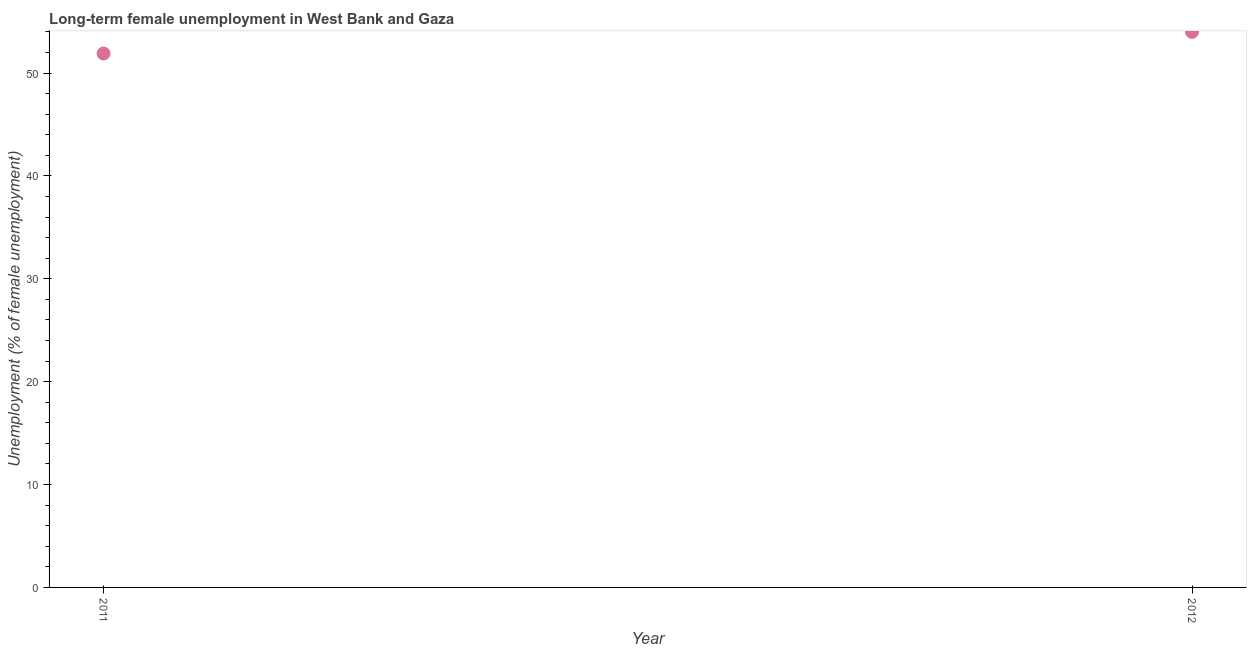What is the long-term female unemployment in 2011?
Give a very brief answer. 51.9. Across all years, what is the maximum long-term female unemployment?
Give a very brief answer. 54. Across all years, what is the minimum long-term female unemployment?
Offer a very short reply. 51.9. What is the sum of the long-term female unemployment?
Provide a short and direct response. 105.9. What is the difference between the long-term female unemployment in 2011 and 2012?
Provide a succinct answer. -2.1. What is the average long-term female unemployment per year?
Offer a very short reply. 52.95. What is the median long-term female unemployment?
Keep it short and to the point. 52.95. In how many years, is the long-term female unemployment greater than 6 %?
Offer a very short reply. 2. Do a majority of the years between 2012 and 2011 (inclusive) have long-term female unemployment greater than 38 %?
Offer a terse response. No. What is the ratio of the long-term female unemployment in 2011 to that in 2012?
Offer a terse response. 0.96. Is the long-term female unemployment in 2011 less than that in 2012?
Ensure brevity in your answer.  Yes. In how many years, is the long-term female unemployment greater than the average long-term female unemployment taken over all years?
Offer a terse response. 1. How many dotlines are there?
Ensure brevity in your answer.  1. How many years are there in the graph?
Give a very brief answer. 2. What is the difference between two consecutive major ticks on the Y-axis?
Provide a short and direct response. 10. What is the title of the graph?
Ensure brevity in your answer.  Long-term female unemployment in West Bank and Gaza. What is the label or title of the Y-axis?
Make the answer very short. Unemployment (% of female unemployment). What is the Unemployment (% of female unemployment) in 2011?
Offer a very short reply. 51.9. What is the Unemployment (% of female unemployment) in 2012?
Your answer should be very brief. 54. What is the difference between the Unemployment (% of female unemployment) in 2011 and 2012?
Ensure brevity in your answer.  -2.1. 